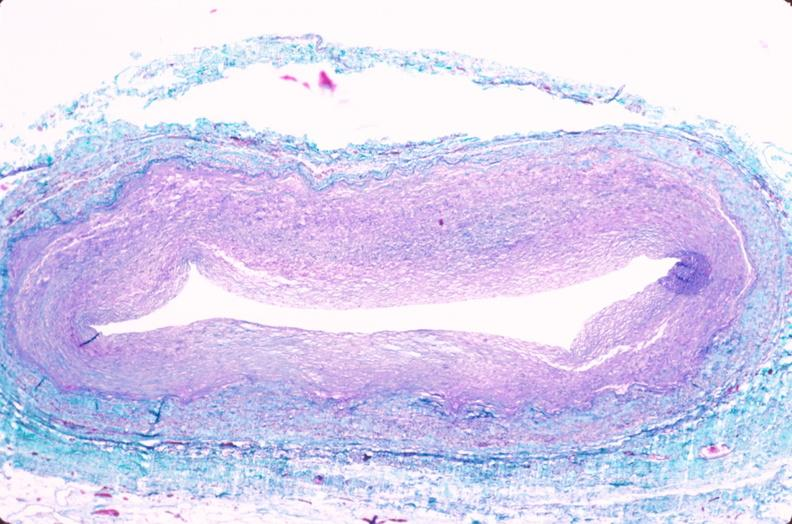s peritoneum present?
Answer the question using a single word or phrase. No 